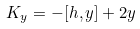Convert formula to latex. <formula><loc_0><loc_0><loc_500><loc_500>K _ { y } = - [ h , y ] + 2 y</formula> 